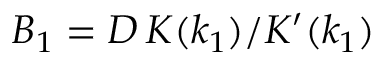<formula> <loc_0><loc_0><loc_500><loc_500>B _ { 1 } = D \, K ( k _ { 1 } ) / K ^ { \prime } ( k _ { 1 } )</formula> 